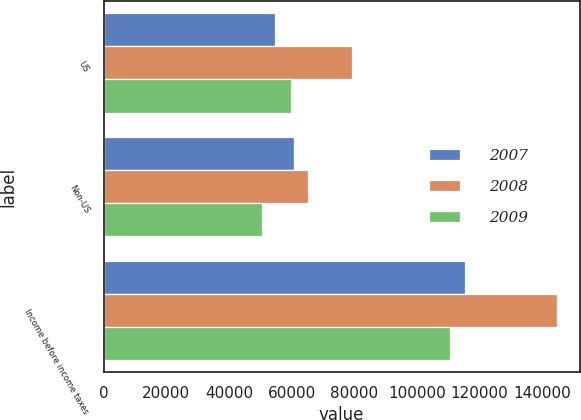Convert chart to OTSL. <chart><loc_0><loc_0><loc_500><loc_500><stacked_bar_chart><ecel><fcel>US<fcel>Non-US<fcel>Income before income taxes<nl><fcel>2007<fcel>54793<fcel>60733<fcel>115526<nl><fcel>2008<fcel>79393<fcel>65348<fcel>144741<nl><fcel>2009<fcel>59884<fcel>50613<fcel>110497<nl></chart> 